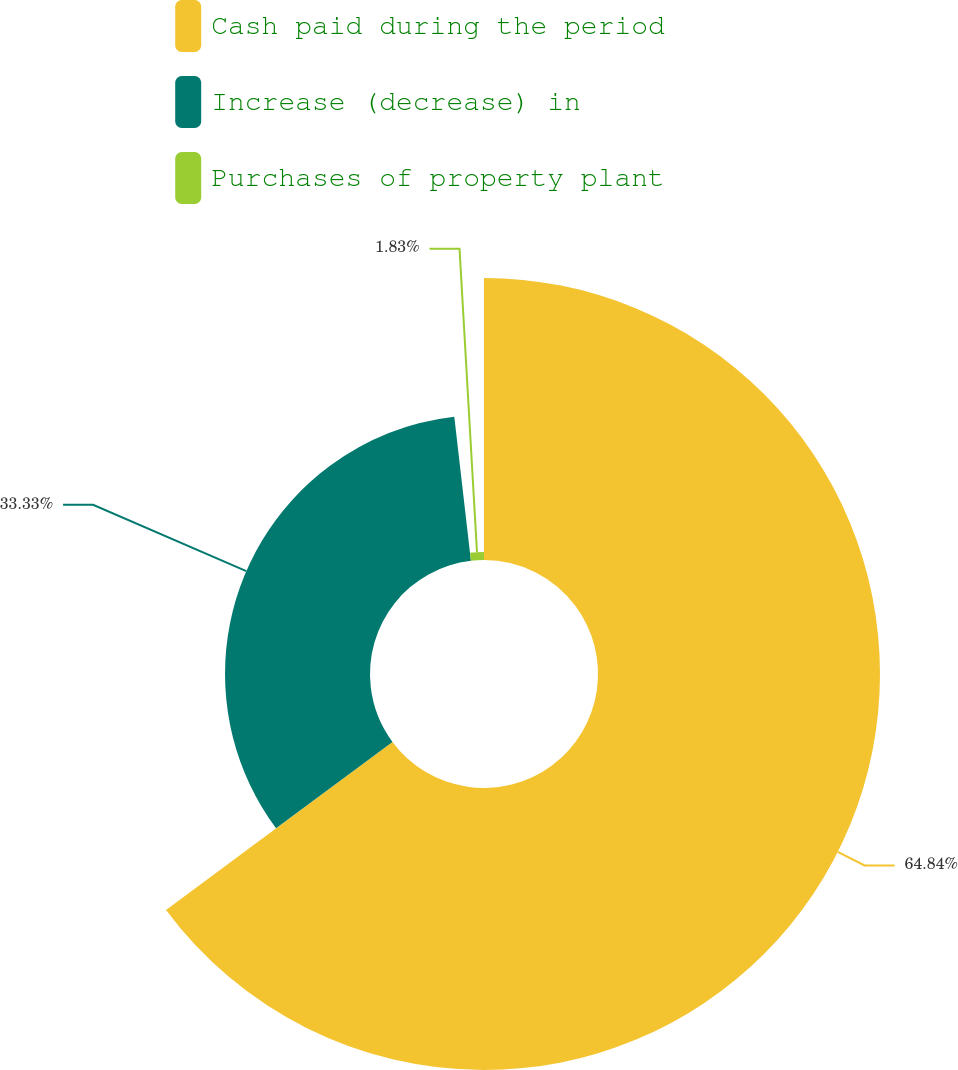Convert chart to OTSL. <chart><loc_0><loc_0><loc_500><loc_500><pie_chart><fcel>Cash paid during the period<fcel>Increase (decrease) in<fcel>Purchases of property plant<nl><fcel>64.83%<fcel>33.33%<fcel>1.83%<nl></chart> 